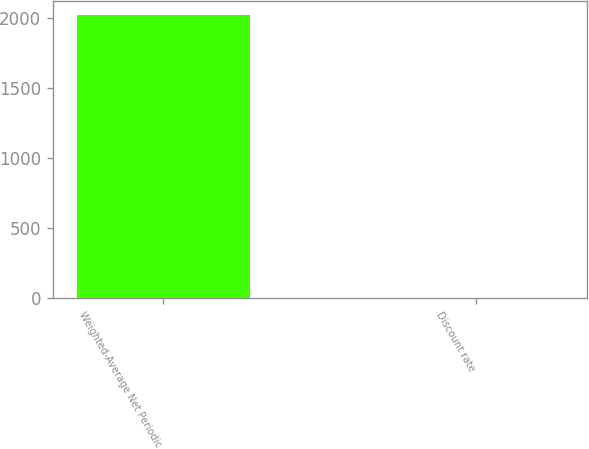<chart> <loc_0><loc_0><loc_500><loc_500><bar_chart><fcel>Weighted-Average Net Periodic<fcel>Discount rate<nl><fcel>2016<fcel>1.3<nl></chart> 